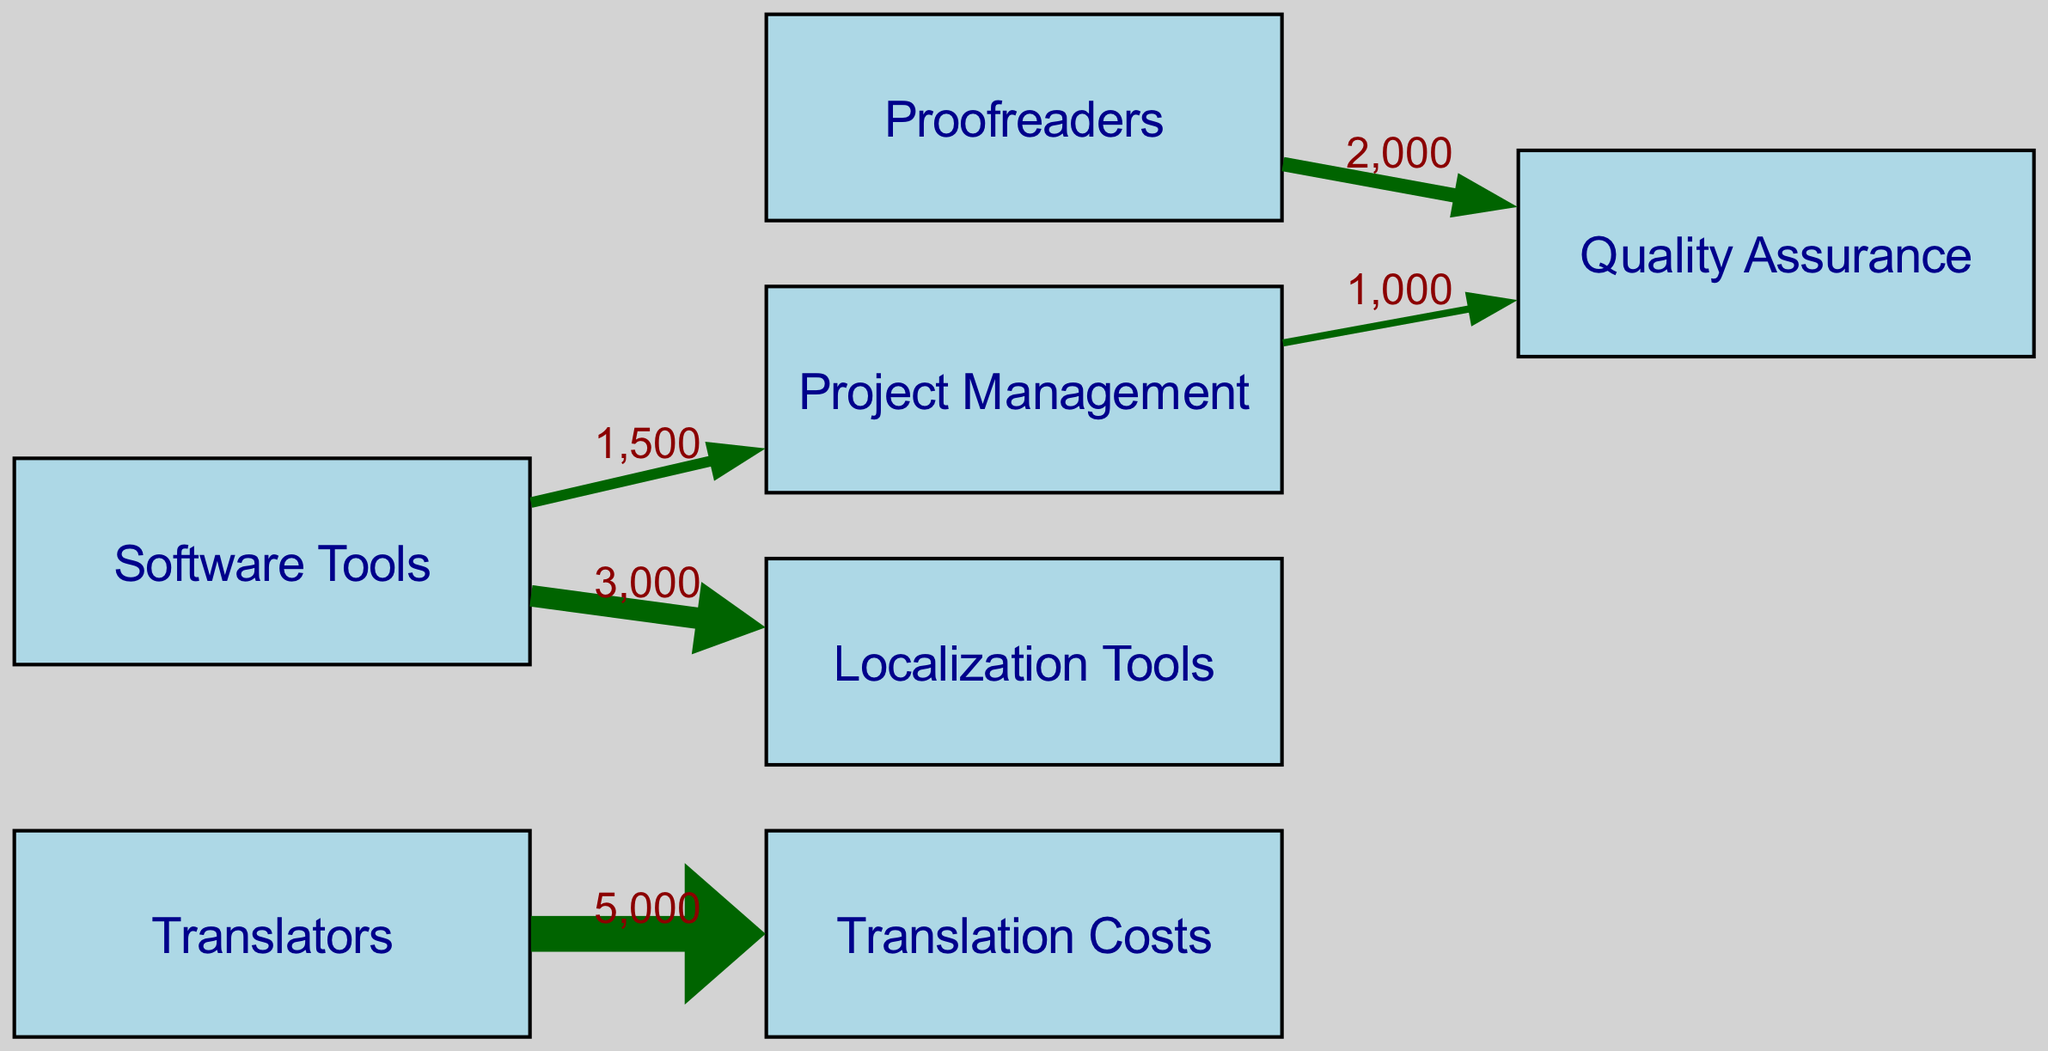What is the total cost allocated to translators? The flow from the "Translators" node to "Translation Costs" shows a value of 5000. Therefore, the total cost allocated to translators is simply this value.
Answer: 5000 How many links are there in the diagram? Counting the links listed, there are a total of 5 connections made between the nodes. This includes connections from "Translators," "Proofreaders," and "Software Tools" to their respective targets.
Answer: 5 What is the cost associated with proofreading? The arrow leading from "Proofreaders" to "Quality Assurance" indicates a value of 2000, which represents the cost associated with proofreading.
Answer: 2000 Which node has the highest allocation? The "Translators" node leads to "Translation Costs" with the highest value of 5000 compared to the other connections, indicating this is the highest allocation in the diagram.
Answer: Translators What is the total cost of software tools? The links from "Software Tools" lead to both "Project Management" (1500) and "Localization Tools" (3000). Adding these values together (1500 + 3000) gives a total of 4500, which represents the total cost of software tools.
Answer: 4500 What is the relationship between project management and quality assurance? The arrow from "Project Management" to "Quality Assurance" shows a value of 1000, indicating that project management contributes 1000 to quality assurance, establishing a direct relationship between the two.
Answer: 1000 Which node connects directly to quality assurance? The "Proofreaders" and "Project Management" nodes both have direct links leading into "Quality Assurance," indicating they both contribute directly to it.
Answer: Proofreaders, Project Management How much does software tools contribute to localization tools? The link from "Software Tools" to "Localization Tools" has a value of 3000, demonstrating that this is the exact contribution of software tools towards localization tools.
Answer: 3000 What is the combined cost flowing from "Software Tools"? Adding the values from the links of "Software Tools" - 1500 to "Project Management" and 3000 to "Localization Tools," the combined cost is 4500.
Answer: 4500 